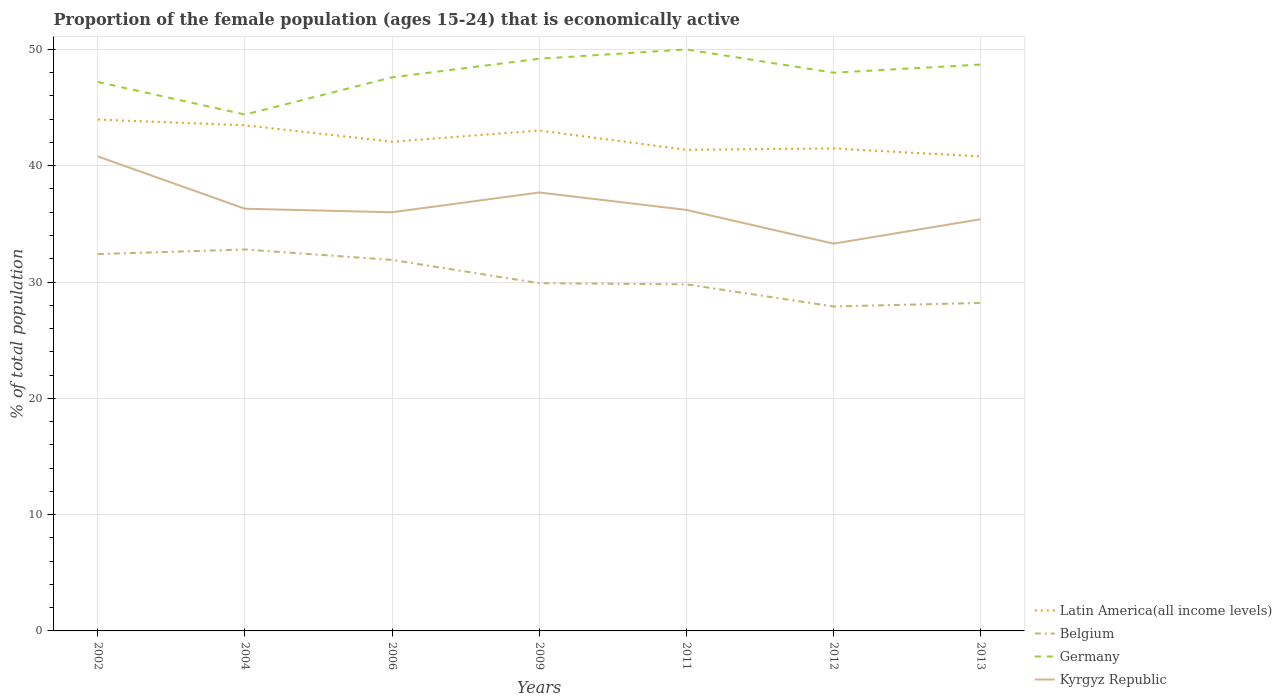Does the line corresponding to Belgium intersect with the line corresponding to Kyrgyz Republic?
Your response must be concise. No. Across all years, what is the maximum proportion of the female population that is economically active in Kyrgyz Republic?
Your answer should be compact. 33.3. In which year was the proportion of the female population that is economically active in Kyrgyz Republic maximum?
Your answer should be very brief. 2012. What is the total proportion of the female population that is economically active in Germany in the graph?
Offer a very short reply. 2. What is the difference between the highest and the second highest proportion of the female population that is economically active in Germany?
Ensure brevity in your answer.  5.6. Is the proportion of the female population that is economically active in Belgium strictly greater than the proportion of the female population that is economically active in Kyrgyz Republic over the years?
Give a very brief answer. Yes. How many lines are there?
Keep it short and to the point. 4. What is the difference between two consecutive major ticks on the Y-axis?
Ensure brevity in your answer.  10. Are the values on the major ticks of Y-axis written in scientific E-notation?
Your response must be concise. No. Does the graph contain any zero values?
Offer a very short reply. No. Does the graph contain grids?
Ensure brevity in your answer.  Yes. How are the legend labels stacked?
Offer a terse response. Vertical. What is the title of the graph?
Ensure brevity in your answer.  Proportion of the female population (ages 15-24) that is economically active. Does "Morocco" appear as one of the legend labels in the graph?
Offer a very short reply. No. What is the label or title of the X-axis?
Offer a very short reply. Years. What is the label or title of the Y-axis?
Make the answer very short. % of total population. What is the % of total population of Latin America(all income levels) in 2002?
Provide a short and direct response. 43.97. What is the % of total population of Belgium in 2002?
Your response must be concise. 32.4. What is the % of total population in Germany in 2002?
Your answer should be very brief. 47.2. What is the % of total population in Kyrgyz Republic in 2002?
Your answer should be compact. 40.8. What is the % of total population in Latin America(all income levels) in 2004?
Your answer should be very brief. 43.48. What is the % of total population in Belgium in 2004?
Your response must be concise. 32.8. What is the % of total population in Germany in 2004?
Offer a terse response. 44.4. What is the % of total population of Kyrgyz Republic in 2004?
Give a very brief answer. 36.3. What is the % of total population in Latin America(all income levels) in 2006?
Keep it short and to the point. 42.06. What is the % of total population of Belgium in 2006?
Make the answer very short. 31.9. What is the % of total population in Germany in 2006?
Ensure brevity in your answer.  47.6. What is the % of total population of Kyrgyz Republic in 2006?
Your response must be concise. 36. What is the % of total population of Latin America(all income levels) in 2009?
Your answer should be compact. 43.03. What is the % of total population of Belgium in 2009?
Provide a short and direct response. 29.9. What is the % of total population in Germany in 2009?
Offer a very short reply. 49.2. What is the % of total population of Kyrgyz Republic in 2009?
Make the answer very short. 37.7. What is the % of total population in Latin America(all income levels) in 2011?
Your answer should be compact. 41.37. What is the % of total population in Belgium in 2011?
Your answer should be very brief. 29.8. What is the % of total population in Kyrgyz Republic in 2011?
Ensure brevity in your answer.  36.2. What is the % of total population in Latin America(all income levels) in 2012?
Provide a short and direct response. 41.48. What is the % of total population in Belgium in 2012?
Give a very brief answer. 27.9. What is the % of total population in Germany in 2012?
Your answer should be very brief. 48. What is the % of total population in Kyrgyz Republic in 2012?
Keep it short and to the point. 33.3. What is the % of total population in Latin America(all income levels) in 2013?
Provide a short and direct response. 40.8. What is the % of total population of Belgium in 2013?
Your response must be concise. 28.2. What is the % of total population in Germany in 2013?
Give a very brief answer. 48.7. What is the % of total population in Kyrgyz Republic in 2013?
Ensure brevity in your answer.  35.4. Across all years, what is the maximum % of total population in Latin America(all income levels)?
Make the answer very short. 43.97. Across all years, what is the maximum % of total population in Belgium?
Your response must be concise. 32.8. Across all years, what is the maximum % of total population in Germany?
Your answer should be compact. 50. Across all years, what is the maximum % of total population in Kyrgyz Republic?
Give a very brief answer. 40.8. Across all years, what is the minimum % of total population of Latin America(all income levels)?
Your answer should be compact. 40.8. Across all years, what is the minimum % of total population of Belgium?
Your answer should be very brief. 27.9. Across all years, what is the minimum % of total population in Germany?
Your answer should be compact. 44.4. Across all years, what is the minimum % of total population of Kyrgyz Republic?
Your answer should be very brief. 33.3. What is the total % of total population of Latin America(all income levels) in the graph?
Your answer should be very brief. 296.19. What is the total % of total population in Belgium in the graph?
Ensure brevity in your answer.  212.9. What is the total % of total population of Germany in the graph?
Offer a terse response. 335.1. What is the total % of total population of Kyrgyz Republic in the graph?
Provide a short and direct response. 255.7. What is the difference between the % of total population of Latin America(all income levels) in 2002 and that in 2004?
Ensure brevity in your answer.  0.5. What is the difference between the % of total population of Belgium in 2002 and that in 2004?
Provide a short and direct response. -0.4. What is the difference between the % of total population of Germany in 2002 and that in 2004?
Ensure brevity in your answer.  2.8. What is the difference between the % of total population in Latin America(all income levels) in 2002 and that in 2006?
Offer a very short reply. 1.91. What is the difference between the % of total population in Belgium in 2002 and that in 2006?
Your answer should be very brief. 0.5. What is the difference between the % of total population in Latin America(all income levels) in 2002 and that in 2009?
Offer a terse response. 0.94. What is the difference between the % of total population of Belgium in 2002 and that in 2009?
Keep it short and to the point. 2.5. What is the difference between the % of total population in Latin America(all income levels) in 2002 and that in 2011?
Provide a succinct answer. 2.6. What is the difference between the % of total population in Kyrgyz Republic in 2002 and that in 2011?
Your response must be concise. 4.6. What is the difference between the % of total population in Latin America(all income levels) in 2002 and that in 2012?
Keep it short and to the point. 2.49. What is the difference between the % of total population of Belgium in 2002 and that in 2012?
Ensure brevity in your answer.  4.5. What is the difference between the % of total population in Kyrgyz Republic in 2002 and that in 2012?
Provide a short and direct response. 7.5. What is the difference between the % of total population of Latin America(all income levels) in 2002 and that in 2013?
Provide a succinct answer. 3.17. What is the difference between the % of total population of Belgium in 2002 and that in 2013?
Your answer should be compact. 4.2. What is the difference between the % of total population of Germany in 2002 and that in 2013?
Offer a terse response. -1.5. What is the difference between the % of total population of Latin America(all income levels) in 2004 and that in 2006?
Give a very brief answer. 1.41. What is the difference between the % of total population in Kyrgyz Republic in 2004 and that in 2006?
Provide a short and direct response. 0.3. What is the difference between the % of total population of Latin America(all income levels) in 2004 and that in 2009?
Give a very brief answer. 0.45. What is the difference between the % of total population in Germany in 2004 and that in 2009?
Offer a terse response. -4.8. What is the difference between the % of total population of Latin America(all income levels) in 2004 and that in 2011?
Offer a terse response. 2.11. What is the difference between the % of total population in Belgium in 2004 and that in 2011?
Ensure brevity in your answer.  3. What is the difference between the % of total population in Germany in 2004 and that in 2011?
Provide a succinct answer. -5.6. What is the difference between the % of total population of Kyrgyz Republic in 2004 and that in 2011?
Keep it short and to the point. 0.1. What is the difference between the % of total population in Latin America(all income levels) in 2004 and that in 2012?
Your response must be concise. 1.99. What is the difference between the % of total population of Belgium in 2004 and that in 2012?
Keep it short and to the point. 4.9. What is the difference between the % of total population in Latin America(all income levels) in 2004 and that in 2013?
Provide a succinct answer. 2.67. What is the difference between the % of total population in Belgium in 2004 and that in 2013?
Keep it short and to the point. 4.6. What is the difference between the % of total population in Latin America(all income levels) in 2006 and that in 2009?
Keep it short and to the point. -0.96. What is the difference between the % of total population of Belgium in 2006 and that in 2009?
Make the answer very short. 2. What is the difference between the % of total population of Germany in 2006 and that in 2009?
Provide a succinct answer. -1.6. What is the difference between the % of total population of Latin America(all income levels) in 2006 and that in 2011?
Provide a succinct answer. 0.69. What is the difference between the % of total population in Kyrgyz Republic in 2006 and that in 2011?
Your answer should be very brief. -0.2. What is the difference between the % of total population in Latin America(all income levels) in 2006 and that in 2012?
Your answer should be compact. 0.58. What is the difference between the % of total population in Belgium in 2006 and that in 2012?
Offer a terse response. 4. What is the difference between the % of total population of Germany in 2006 and that in 2012?
Provide a succinct answer. -0.4. What is the difference between the % of total population in Kyrgyz Republic in 2006 and that in 2012?
Your answer should be very brief. 2.7. What is the difference between the % of total population in Latin America(all income levels) in 2006 and that in 2013?
Your response must be concise. 1.26. What is the difference between the % of total population in Belgium in 2006 and that in 2013?
Keep it short and to the point. 3.7. What is the difference between the % of total population in Kyrgyz Republic in 2006 and that in 2013?
Keep it short and to the point. 0.6. What is the difference between the % of total population in Latin America(all income levels) in 2009 and that in 2011?
Your answer should be very brief. 1.66. What is the difference between the % of total population of Belgium in 2009 and that in 2011?
Your response must be concise. 0.1. What is the difference between the % of total population of Germany in 2009 and that in 2011?
Ensure brevity in your answer.  -0.8. What is the difference between the % of total population of Latin America(all income levels) in 2009 and that in 2012?
Your response must be concise. 1.54. What is the difference between the % of total population of Germany in 2009 and that in 2012?
Your response must be concise. 1.2. What is the difference between the % of total population in Latin America(all income levels) in 2009 and that in 2013?
Give a very brief answer. 2.23. What is the difference between the % of total population in Belgium in 2009 and that in 2013?
Your response must be concise. 1.7. What is the difference between the % of total population in Germany in 2009 and that in 2013?
Ensure brevity in your answer.  0.5. What is the difference between the % of total population in Kyrgyz Republic in 2009 and that in 2013?
Give a very brief answer. 2.3. What is the difference between the % of total population of Latin America(all income levels) in 2011 and that in 2012?
Keep it short and to the point. -0.11. What is the difference between the % of total population in Belgium in 2011 and that in 2012?
Ensure brevity in your answer.  1.9. What is the difference between the % of total population in Kyrgyz Republic in 2011 and that in 2012?
Your answer should be compact. 2.9. What is the difference between the % of total population in Latin America(all income levels) in 2011 and that in 2013?
Make the answer very short. 0.57. What is the difference between the % of total population of Belgium in 2011 and that in 2013?
Your answer should be very brief. 1.6. What is the difference between the % of total population in Germany in 2011 and that in 2013?
Provide a succinct answer. 1.3. What is the difference between the % of total population in Latin America(all income levels) in 2012 and that in 2013?
Offer a terse response. 0.68. What is the difference between the % of total population in Belgium in 2012 and that in 2013?
Keep it short and to the point. -0.3. What is the difference between the % of total population of Kyrgyz Republic in 2012 and that in 2013?
Provide a short and direct response. -2.1. What is the difference between the % of total population in Latin America(all income levels) in 2002 and the % of total population in Belgium in 2004?
Keep it short and to the point. 11.17. What is the difference between the % of total population of Latin America(all income levels) in 2002 and the % of total population of Germany in 2004?
Keep it short and to the point. -0.43. What is the difference between the % of total population in Latin America(all income levels) in 2002 and the % of total population in Kyrgyz Republic in 2004?
Give a very brief answer. 7.67. What is the difference between the % of total population of Belgium in 2002 and the % of total population of Germany in 2004?
Keep it short and to the point. -12. What is the difference between the % of total population in Belgium in 2002 and the % of total population in Kyrgyz Republic in 2004?
Your answer should be very brief. -3.9. What is the difference between the % of total population in Latin America(all income levels) in 2002 and the % of total population in Belgium in 2006?
Keep it short and to the point. 12.07. What is the difference between the % of total population in Latin America(all income levels) in 2002 and the % of total population in Germany in 2006?
Provide a short and direct response. -3.63. What is the difference between the % of total population of Latin America(all income levels) in 2002 and the % of total population of Kyrgyz Republic in 2006?
Keep it short and to the point. 7.97. What is the difference between the % of total population of Belgium in 2002 and the % of total population of Germany in 2006?
Make the answer very short. -15.2. What is the difference between the % of total population in Latin America(all income levels) in 2002 and the % of total population in Belgium in 2009?
Your response must be concise. 14.07. What is the difference between the % of total population of Latin America(all income levels) in 2002 and the % of total population of Germany in 2009?
Give a very brief answer. -5.23. What is the difference between the % of total population of Latin America(all income levels) in 2002 and the % of total population of Kyrgyz Republic in 2009?
Give a very brief answer. 6.27. What is the difference between the % of total population in Belgium in 2002 and the % of total population in Germany in 2009?
Make the answer very short. -16.8. What is the difference between the % of total population of Latin America(all income levels) in 2002 and the % of total population of Belgium in 2011?
Provide a short and direct response. 14.17. What is the difference between the % of total population of Latin America(all income levels) in 2002 and the % of total population of Germany in 2011?
Give a very brief answer. -6.03. What is the difference between the % of total population in Latin America(all income levels) in 2002 and the % of total population in Kyrgyz Republic in 2011?
Give a very brief answer. 7.77. What is the difference between the % of total population in Belgium in 2002 and the % of total population in Germany in 2011?
Your answer should be very brief. -17.6. What is the difference between the % of total population of Belgium in 2002 and the % of total population of Kyrgyz Republic in 2011?
Ensure brevity in your answer.  -3.8. What is the difference between the % of total population of Germany in 2002 and the % of total population of Kyrgyz Republic in 2011?
Keep it short and to the point. 11. What is the difference between the % of total population in Latin America(all income levels) in 2002 and the % of total population in Belgium in 2012?
Provide a short and direct response. 16.07. What is the difference between the % of total population of Latin America(all income levels) in 2002 and the % of total population of Germany in 2012?
Your answer should be very brief. -4.03. What is the difference between the % of total population of Latin America(all income levels) in 2002 and the % of total population of Kyrgyz Republic in 2012?
Make the answer very short. 10.67. What is the difference between the % of total population in Belgium in 2002 and the % of total population in Germany in 2012?
Offer a very short reply. -15.6. What is the difference between the % of total population of Latin America(all income levels) in 2002 and the % of total population of Belgium in 2013?
Offer a very short reply. 15.77. What is the difference between the % of total population of Latin America(all income levels) in 2002 and the % of total population of Germany in 2013?
Make the answer very short. -4.73. What is the difference between the % of total population in Latin America(all income levels) in 2002 and the % of total population in Kyrgyz Republic in 2013?
Your answer should be very brief. 8.57. What is the difference between the % of total population in Belgium in 2002 and the % of total population in Germany in 2013?
Provide a succinct answer. -16.3. What is the difference between the % of total population in Belgium in 2002 and the % of total population in Kyrgyz Republic in 2013?
Give a very brief answer. -3. What is the difference between the % of total population in Latin America(all income levels) in 2004 and the % of total population in Belgium in 2006?
Offer a very short reply. 11.58. What is the difference between the % of total population in Latin America(all income levels) in 2004 and the % of total population in Germany in 2006?
Your answer should be compact. -4.12. What is the difference between the % of total population in Latin America(all income levels) in 2004 and the % of total population in Kyrgyz Republic in 2006?
Keep it short and to the point. 7.48. What is the difference between the % of total population in Belgium in 2004 and the % of total population in Germany in 2006?
Provide a succinct answer. -14.8. What is the difference between the % of total population in Germany in 2004 and the % of total population in Kyrgyz Republic in 2006?
Provide a succinct answer. 8.4. What is the difference between the % of total population of Latin America(all income levels) in 2004 and the % of total population of Belgium in 2009?
Ensure brevity in your answer.  13.58. What is the difference between the % of total population of Latin America(all income levels) in 2004 and the % of total population of Germany in 2009?
Offer a terse response. -5.72. What is the difference between the % of total population in Latin America(all income levels) in 2004 and the % of total population in Kyrgyz Republic in 2009?
Make the answer very short. 5.78. What is the difference between the % of total population in Belgium in 2004 and the % of total population in Germany in 2009?
Your answer should be very brief. -16.4. What is the difference between the % of total population in Latin America(all income levels) in 2004 and the % of total population in Belgium in 2011?
Your answer should be compact. 13.68. What is the difference between the % of total population in Latin America(all income levels) in 2004 and the % of total population in Germany in 2011?
Offer a very short reply. -6.52. What is the difference between the % of total population in Latin America(all income levels) in 2004 and the % of total population in Kyrgyz Republic in 2011?
Give a very brief answer. 7.28. What is the difference between the % of total population of Belgium in 2004 and the % of total population of Germany in 2011?
Ensure brevity in your answer.  -17.2. What is the difference between the % of total population in Latin America(all income levels) in 2004 and the % of total population in Belgium in 2012?
Offer a terse response. 15.58. What is the difference between the % of total population in Latin America(all income levels) in 2004 and the % of total population in Germany in 2012?
Give a very brief answer. -4.52. What is the difference between the % of total population of Latin America(all income levels) in 2004 and the % of total population of Kyrgyz Republic in 2012?
Provide a succinct answer. 10.18. What is the difference between the % of total population of Belgium in 2004 and the % of total population of Germany in 2012?
Your answer should be very brief. -15.2. What is the difference between the % of total population in Latin America(all income levels) in 2004 and the % of total population in Belgium in 2013?
Make the answer very short. 15.28. What is the difference between the % of total population of Latin America(all income levels) in 2004 and the % of total population of Germany in 2013?
Ensure brevity in your answer.  -5.22. What is the difference between the % of total population of Latin America(all income levels) in 2004 and the % of total population of Kyrgyz Republic in 2013?
Your answer should be compact. 8.08. What is the difference between the % of total population in Belgium in 2004 and the % of total population in Germany in 2013?
Keep it short and to the point. -15.9. What is the difference between the % of total population of Latin America(all income levels) in 2006 and the % of total population of Belgium in 2009?
Your answer should be compact. 12.16. What is the difference between the % of total population in Latin America(all income levels) in 2006 and the % of total population in Germany in 2009?
Keep it short and to the point. -7.14. What is the difference between the % of total population in Latin America(all income levels) in 2006 and the % of total population in Kyrgyz Republic in 2009?
Provide a succinct answer. 4.36. What is the difference between the % of total population in Belgium in 2006 and the % of total population in Germany in 2009?
Ensure brevity in your answer.  -17.3. What is the difference between the % of total population of Belgium in 2006 and the % of total population of Kyrgyz Republic in 2009?
Ensure brevity in your answer.  -5.8. What is the difference between the % of total population of Latin America(all income levels) in 2006 and the % of total population of Belgium in 2011?
Offer a terse response. 12.26. What is the difference between the % of total population in Latin America(all income levels) in 2006 and the % of total population in Germany in 2011?
Offer a terse response. -7.94. What is the difference between the % of total population in Latin America(all income levels) in 2006 and the % of total population in Kyrgyz Republic in 2011?
Provide a short and direct response. 5.86. What is the difference between the % of total population of Belgium in 2006 and the % of total population of Germany in 2011?
Your answer should be very brief. -18.1. What is the difference between the % of total population of Belgium in 2006 and the % of total population of Kyrgyz Republic in 2011?
Ensure brevity in your answer.  -4.3. What is the difference between the % of total population of Latin America(all income levels) in 2006 and the % of total population of Belgium in 2012?
Your response must be concise. 14.16. What is the difference between the % of total population of Latin America(all income levels) in 2006 and the % of total population of Germany in 2012?
Your answer should be very brief. -5.94. What is the difference between the % of total population of Latin America(all income levels) in 2006 and the % of total population of Kyrgyz Republic in 2012?
Offer a very short reply. 8.76. What is the difference between the % of total population in Belgium in 2006 and the % of total population in Germany in 2012?
Your answer should be very brief. -16.1. What is the difference between the % of total population in Germany in 2006 and the % of total population in Kyrgyz Republic in 2012?
Your answer should be very brief. 14.3. What is the difference between the % of total population in Latin America(all income levels) in 2006 and the % of total population in Belgium in 2013?
Make the answer very short. 13.86. What is the difference between the % of total population of Latin America(all income levels) in 2006 and the % of total population of Germany in 2013?
Provide a short and direct response. -6.64. What is the difference between the % of total population of Latin America(all income levels) in 2006 and the % of total population of Kyrgyz Republic in 2013?
Your answer should be compact. 6.66. What is the difference between the % of total population in Belgium in 2006 and the % of total population in Germany in 2013?
Your response must be concise. -16.8. What is the difference between the % of total population of Belgium in 2006 and the % of total population of Kyrgyz Republic in 2013?
Give a very brief answer. -3.5. What is the difference between the % of total population of Germany in 2006 and the % of total population of Kyrgyz Republic in 2013?
Give a very brief answer. 12.2. What is the difference between the % of total population in Latin America(all income levels) in 2009 and the % of total population in Belgium in 2011?
Keep it short and to the point. 13.23. What is the difference between the % of total population of Latin America(all income levels) in 2009 and the % of total population of Germany in 2011?
Offer a very short reply. -6.97. What is the difference between the % of total population of Latin America(all income levels) in 2009 and the % of total population of Kyrgyz Republic in 2011?
Ensure brevity in your answer.  6.83. What is the difference between the % of total population in Belgium in 2009 and the % of total population in Germany in 2011?
Give a very brief answer. -20.1. What is the difference between the % of total population of Germany in 2009 and the % of total population of Kyrgyz Republic in 2011?
Your response must be concise. 13. What is the difference between the % of total population of Latin America(all income levels) in 2009 and the % of total population of Belgium in 2012?
Offer a very short reply. 15.13. What is the difference between the % of total population of Latin America(all income levels) in 2009 and the % of total population of Germany in 2012?
Offer a terse response. -4.97. What is the difference between the % of total population in Latin America(all income levels) in 2009 and the % of total population in Kyrgyz Republic in 2012?
Give a very brief answer. 9.73. What is the difference between the % of total population of Belgium in 2009 and the % of total population of Germany in 2012?
Offer a terse response. -18.1. What is the difference between the % of total population of Latin America(all income levels) in 2009 and the % of total population of Belgium in 2013?
Provide a short and direct response. 14.83. What is the difference between the % of total population in Latin America(all income levels) in 2009 and the % of total population in Germany in 2013?
Provide a short and direct response. -5.67. What is the difference between the % of total population of Latin America(all income levels) in 2009 and the % of total population of Kyrgyz Republic in 2013?
Give a very brief answer. 7.63. What is the difference between the % of total population in Belgium in 2009 and the % of total population in Germany in 2013?
Offer a very short reply. -18.8. What is the difference between the % of total population of Latin America(all income levels) in 2011 and the % of total population of Belgium in 2012?
Your answer should be very brief. 13.47. What is the difference between the % of total population in Latin America(all income levels) in 2011 and the % of total population in Germany in 2012?
Provide a short and direct response. -6.63. What is the difference between the % of total population in Latin America(all income levels) in 2011 and the % of total population in Kyrgyz Republic in 2012?
Provide a short and direct response. 8.07. What is the difference between the % of total population in Belgium in 2011 and the % of total population in Germany in 2012?
Keep it short and to the point. -18.2. What is the difference between the % of total population in Germany in 2011 and the % of total population in Kyrgyz Republic in 2012?
Make the answer very short. 16.7. What is the difference between the % of total population of Latin America(all income levels) in 2011 and the % of total population of Belgium in 2013?
Keep it short and to the point. 13.17. What is the difference between the % of total population of Latin America(all income levels) in 2011 and the % of total population of Germany in 2013?
Offer a very short reply. -7.33. What is the difference between the % of total population of Latin America(all income levels) in 2011 and the % of total population of Kyrgyz Republic in 2013?
Keep it short and to the point. 5.97. What is the difference between the % of total population of Belgium in 2011 and the % of total population of Germany in 2013?
Your answer should be compact. -18.9. What is the difference between the % of total population in Belgium in 2011 and the % of total population in Kyrgyz Republic in 2013?
Provide a short and direct response. -5.6. What is the difference between the % of total population in Latin America(all income levels) in 2012 and the % of total population in Belgium in 2013?
Ensure brevity in your answer.  13.28. What is the difference between the % of total population of Latin America(all income levels) in 2012 and the % of total population of Germany in 2013?
Provide a succinct answer. -7.22. What is the difference between the % of total population in Latin America(all income levels) in 2012 and the % of total population in Kyrgyz Republic in 2013?
Your response must be concise. 6.08. What is the difference between the % of total population in Belgium in 2012 and the % of total population in Germany in 2013?
Provide a succinct answer. -20.8. What is the difference between the % of total population of Germany in 2012 and the % of total population of Kyrgyz Republic in 2013?
Give a very brief answer. 12.6. What is the average % of total population in Latin America(all income levels) per year?
Ensure brevity in your answer.  42.31. What is the average % of total population of Belgium per year?
Provide a short and direct response. 30.41. What is the average % of total population of Germany per year?
Offer a terse response. 47.87. What is the average % of total population in Kyrgyz Republic per year?
Offer a very short reply. 36.53. In the year 2002, what is the difference between the % of total population in Latin America(all income levels) and % of total population in Belgium?
Make the answer very short. 11.57. In the year 2002, what is the difference between the % of total population of Latin America(all income levels) and % of total population of Germany?
Make the answer very short. -3.23. In the year 2002, what is the difference between the % of total population in Latin America(all income levels) and % of total population in Kyrgyz Republic?
Make the answer very short. 3.17. In the year 2002, what is the difference between the % of total population in Belgium and % of total population in Germany?
Keep it short and to the point. -14.8. In the year 2004, what is the difference between the % of total population of Latin America(all income levels) and % of total population of Belgium?
Offer a very short reply. 10.68. In the year 2004, what is the difference between the % of total population in Latin America(all income levels) and % of total population in Germany?
Your answer should be compact. -0.92. In the year 2004, what is the difference between the % of total population in Latin America(all income levels) and % of total population in Kyrgyz Republic?
Keep it short and to the point. 7.18. In the year 2004, what is the difference between the % of total population in Belgium and % of total population in Germany?
Give a very brief answer. -11.6. In the year 2004, what is the difference between the % of total population of Germany and % of total population of Kyrgyz Republic?
Make the answer very short. 8.1. In the year 2006, what is the difference between the % of total population in Latin America(all income levels) and % of total population in Belgium?
Ensure brevity in your answer.  10.16. In the year 2006, what is the difference between the % of total population of Latin America(all income levels) and % of total population of Germany?
Provide a succinct answer. -5.54. In the year 2006, what is the difference between the % of total population in Latin America(all income levels) and % of total population in Kyrgyz Republic?
Your answer should be compact. 6.06. In the year 2006, what is the difference between the % of total population of Belgium and % of total population of Germany?
Your answer should be compact. -15.7. In the year 2006, what is the difference between the % of total population in Germany and % of total population in Kyrgyz Republic?
Your answer should be very brief. 11.6. In the year 2009, what is the difference between the % of total population of Latin America(all income levels) and % of total population of Belgium?
Your answer should be very brief. 13.13. In the year 2009, what is the difference between the % of total population in Latin America(all income levels) and % of total population in Germany?
Give a very brief answer. -6.17. In the year 2009, what is the difference between the % of total population in Latin America(all income levels) and % of total population in Kyrgyz Republic?
Keep it short and to the point. 5.33. In the year 2009, what is the difference between the % of total population of Belgium and % of total population of Germany?
Your answer should be compact. -19.3. In the year 2009, what is the difference between the % of total population of Belgium and % of total population of Kyrgyz Republic?
Keep it short and to the point. -7.8. In the year 2009, what is the difference between the % of total population in Germany and % of total population in Kyrgyz Republic?
Give a very brief answer. 11.5. In the year 2011, what is the difference between the % of total population of Latin America(all income levels) and % of total population of Belgium?
Offer a very short reply. 11.57. In the year 2011, what is the difference between the % of total population of Latin America(all income levels) and % of total population of Germany?
Offer a very short reply. -8.63. In the year 2011, what is the difference between the % of total population of Latin America(all income levels) and % of total population of Kyrgyz Republic?
Your answer should be very brief. 5.17. In the year 2011, what is the difference between the % of total population in Belgium and % of total population in Germany?
Your response must be concise. -20.2. In the year 2012, what is the difference between the % of total population of Latin America(all income levels) and % of total population of Belgium?
Provide a succinct answer. 13.58. In the year 2012, what is the difference between the % of total population in Latin America(all income levels) and % of total population in Germany?
Provide a succinct answer. -6.52. In the year 2012, what is the difference between the % of total population of Latin America(all income levels) and % of total population of Kyrgyz Republic?
Offer a terse response. 8.18. In the year 2012, what is the difference between the % of total population in Belgium and % of total population in Germany?
Ensure brevity in your answer.  -20.1. In the year 2012, what is the difference between the % of total population of Germany and % of total population of Kyrgyz Republic?
Give a very brief answer. 14.7. In the year 2013, what is the difference between the % of total population in Latin America(all income levels) and % of total population in Belgium?
Ensure brevity in your answer.  12.6. In the year 2013, what is the difference between the % of total population in Latin America(all income levels) and % of total population in Germany?
Offer a terse response. -7.9. In the year 2013, what is the difference between the % of total population of Latin America(all income levels) and % of total population of Kyrgyz Republic?
Your response must be concise. 5.4. In the year 2013, what is the difference between the % of total population in Belgium and % of total population in Germany?
Your answer should be compact. -20.5. What is the ratio of the % of total population in Latin America(all income levels) in 2002 to that in 2004?
Your response must be concise. 1.01. What is the ratio of the % of total population in Belgium in 2002 to that in 2004?
Your answer should be very brief. 0.99. What is the ratio of the % of total population of Germany in 2002 to that in 2004?
Offer a very short reply. 1.06. What is the ratio of the % of total population of Kyrgyz Republic in 2002 to that in 2004?
Your answer should be compact. 1.12. What is the ratio of the % of total population in Latin America(all income levels) in 2002 to that in 2006?
Offer a very short reply. 1.05. What is the ratio of the % of total population of Belgium in 2002 to that in 2006?
Provide a succinct answer. 1.02. What is the ratio of the % of total population in Germany in 2002 to that in 2006?
Keep it short and to the point. 0.99. What is the ratio of the % of total population of Kyrgyz Republic in 2002 to that in 2006?
Ensure brevity in your answer.  1.13. What is the ratio of the % of total population of Latin America(all income levels) in 2002 to that in 2009?
Your answer should be very brief. 1.02. What is the ratio of the % of total population in Belgium in 2002 to that in 2009?
Your response must be concise. 1.08. What is the ratio of the % of total population of Germany in 2002 to that in 2009?
Provide a succinct answer. 0.96. What is the ratio of the % of total population in Kyrgyz Republic in 2002 to that in 2009?
Your response must be concise. 1.08. What is the ratio of the % of total population in Latin America(all income levels) in 2002 to that in 2011?
Your answer should be very brief. 1.06. What is the ratio of the % of total population of Belgium in 2002 to that in 2011?
Provide a short and direct response. 1.09. What is the ratio of the % of total population of Germany in 2002 to that in 2011?
Make the answer very short. 0.94. What is the ratio of the % of total population of Kyrgyz Republic in 2002 to that in 2011?
Give a very brief answer. 1.13. What is the ratio of the % of total population in Latin America(all income levels) in 2002 to that in 2012?
Offer a very short reply. 1.06. What is the ratio of the % of total population of Belgium in 2002 to that in 2012?
Ensure brevity in your answer.  1.16. What is the ratio of the % of total population in Germany in 2002 to that in 2012?
Provide a succinct answer. 0.98. What is the ratio of the % of total population in Kyrgyz Republic in 2002 to that in 2012?
Keep it short and to the point. 1.23. What is the ratio of the % of total population of Latin America(all income levels) in 2002 to that in 2013?
Your answer should be very brief. 1.08. What is the ratio of the % of total population in Belgium in 2002 to that in 2013?
Keep it short and to the point. 1.15. What is the ratio of the % of total population in Germany in 2002 to that in 2013?
Give a very brief answer. 0.97. What is the ratio of the % of total population of Kyrgyz Republic in 2002 to that in 2013?
Offer a very short reply. 1.15. What is the ratio of the % of total population in Latin America(all income levels) in 2004 to that in 2006?
Make the answer very short. 1.03. What is the ratio of the % of total population in Belgium in 2004 to that in 2006?
Make the answer very short. 1.03. What is the ratio of the % of total population of Germany in 2004 to that in 2006?
Provide a succinct answer. 0.93. What is the ratio of the % of total population of Kyrgyz Republic in 2004 to that in 2006?
Your answer should be very brief. 1.01. What is the ratio of the % of total population in Latin America(all income levels) in 2004 to that in 2009?
Your answer should be compact. 1.01. What is the ratio of the % of total population of Belgium in 2004 to that in 2009?
Your response must be concise. 1.1. What is the ratio of the % of total population in Germany in 2004 to that in 2009?
Offer a terse response. 0.9. What is the ratio of the % of total population in Kyrgyz Republic in 2004 to that in 2009?
Make the answer very short. 0.96. What is the ratio of the % of total population in Latin America(all income levels) in 2004 to that in 2011?
Offer a very short reply. 1.05. What is the ratio of the % of total population of Belgium in 2004 to that in 2011?
Keep it short and to the point. 1.1. What is the ratio of the % of total population of Germany in 2004 to that in 2011?
Provide a short and direct response. 0.89. What is the ratio of the % of total population in Kyrgyz Republic in 2004 to that in 2011?
Offer a very short reply. 1. What is the ratio of the % of total population of Latin America(all income levels) in 2004 to that in 2012?
Your response must be concise. 1.05. What is the ratio of the % of total population of Belgium in 2004 to that in 2012?
Ensure brevity in your answer.  1.18. What is the ratio of the % of total population in Germany in 2004 to that in 2012?
Your answer should be very brief. 0.93. What is the ratio of the % of total population of Kyrgyz Republic in 2004 to that in 2012?
Your answer should be compact. 1.09. What is the ratio of the % of total population in Latin America(all income levels) in 2004 to that in 2013?
Ensure brevity in your answer.  1.07. What is the ratio of the % of total population in Belgium in 2004 to that in 2013?
Your response must be concise. 1.16. What is the ratio of the % of total population of Germany in 2004 to that in 2013?
Keep it short and to the point. 0.91. What is the ratio of the % of total population of Kyrgyz Republic in 2004 to that in 2013?
Provide a short and direct response. 1.03. What is the ratio of the % of total population of Latin America(all income levels) in 2006 to that in 2009?
Make the answer very short. 0.98. What is the ratio of the % of total population in Belgium in 2006 to that in 2009?
Provide a short and direct response. 1.07. What is the ratio of the % of total population of Germany in 2006 to that in 2009?
Make the answer very short. 0.97. What is the ratio of the % of total population in Kyrgyz Republic in 2006 to that in 2009?
Make the answer very short. 0.95. What is the ratio of the % of total population of Latin America(all income levels) in 2006 to that in 2011?
Provide a short and direct response. 1.02. What is the ratio of the % of total population in Belgium in 2006 to that in 2011?
Keep it short and to the point. 1.07. What is the ratio of the % of total population of Germany in 2006 to that in 2011?
Keep it short and to the point. 0.95. What is the ratio of the % of total population in Kyrgyz Republic in 2006 to that in 2011?
Offer a very short reply. 0.99. What is the ratio of the % of total population of Latin America(all income levels) in 2006 to that in 2012?
Your answer should be very brief. 1.01. What is the ratio of the % of total population in Belgium in 2006 to that in 2012?
Provide a succinct answer. 1.14. What is the ratio of the % of total population in Germany in 2006 to that in 2012?
Make the answer very short. 0.99. What is the ratio of the % of total population in Kyrgyz Republic in 2006 to that in 2012?
Keep it short and to the point. 1.08. What is the ratio of the % of total population in Latin America(all income levels) in 2006 to that in 2013?
Make the answer very short. 1.03. What is the ratio of the % of total population in Belgium in 2006 to that in 2013?
Ensure brevity in your answer.  1.13. What is the ratio of the % of total population of Germany in 2006 to that in 2013?
Keep it short and to the point. 0.98. What is the ratio of the % of total population in Kyrgyz Republic in 2006 to that in 2013?
Ensure brevity in your answer.  1.02. What is the ratio of the % of total population in Latin America(all income levels) in 2009 to that in 2011?
Keep it short and to the point. 1.04. What is the ratio of the % of total population in Germany in 2009 to that in 2011?
Your response must be concise. 0.98. What is the ratio of the % of total population in Kyrgyz Republic in 2009 to that in 2011?
Your response must be concise. 1.04. What is the ratio of the % of total population of Latin America(all income levels) in 2009 to that in 2012?
Your response must be concise. 1.04. What is the ratio of the % of total population in Belgium in 2009 to that in 2012?
Ensure brevity in your answer.  1.07. What is the ratio of the % of total population of Kyrgyz Republic in 2009 to that in 2012?
Offer a terse response. 1.13. What is the ratio of the % of total population in Latin America(all income levels) in 2009 to that in 2013?
Make the answer very short. 1.05. What is the ratio of the % of total population of Belgium in 2009 to that in 2013?
Provide a succinct answer. 1.06. What is the ratio of the % of total population of Germany in 2009 to that in 2013?
Your response must be concise. 1.01. What is the ratio of the % of total population of Kyrgyz Republic in 2009 to that in 2013?
Ensure brevity in your answer.  1.06. What is the ratio of the % of total population of Latin America(all income levels) in 2011 to that in 2012?
Provide a succinct answer. 1. What is the ratio of the % of total population in Belgium in 2011 to that in 2012?
Offer a very short reply. 1.07. What is the ratio of the % of total population in Germany in 2011 to that in 2012?
Keep it short and to the point. 1.04. What is the ratio of the % of total population of Kyrgyz Republic in 2011 to that in 2012?
Make the answer very short. 1.09. What is the ratio of the % of total population in Latin America(all income levels) in 2011 to that in 2013?
Ensure brevity in your answer.  1.01. What is the ratio of the % of total population of Belgium in 2011 to that in 2013?
Your response must be concise. 1.06. What is the ratio of the % of total population in Germany in 2011 to that in 2013?
Your answer should be very brief. 1.03. What is the ratio of the % of total population of Kyrgyz Republic in 2011 to that in 2013?
Offer a terse response. 1.02. What is the ratio of the % of total population of Latin America(all income levels) in 2012 to that in 2013?
Ensure brevity in your answer.  1.02. What is the ratio of the % of total population of Belgium in 2012 to that in 2013?
Give a very brief answer. 0.99. What is the ratio of the % of total population in Germany in 2012 to that in 2013?
Your answer should be very brief. 0.99. What is the ratio of the % of total population in Kyrgyz Republic in 2012 to that in 2013?
Give a very brief answer. 0.94. What is the difference between the highest and the second highest % of total population of Latin America(all income levels)?
Your answer should be very brief. 0.5. What is the difference between the highest and the second highest % of total population in Belgium?
Your answer should be compact. 0.4. What is the difference between the highest and the lowest % of total population in Latin America(all income levels)?
Give a very brief answer. 3.17. What is the difference between the highest and the lowest % of total population in Belgium?
Offer a very short reply. 4.9. 